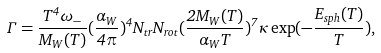<formula> <loc_0><loc_0><loc_500><loc_500>\Gamma = \frac { T ^ { 4 } \omega _ { - } } { M _ { W } ( T ) } ( \frac { \alpha _ { W } } { 4 \pi } ) ^ { 4 } N _ { t r } N _ { r o t } ( \frac { 2 M _ { W } ( T ) } { \alpha _ { W } T } ) ^ { 7 } \kappa \exp ( - \frac { E _ { s p h } ( T ) } { T } ) ,</formula> 